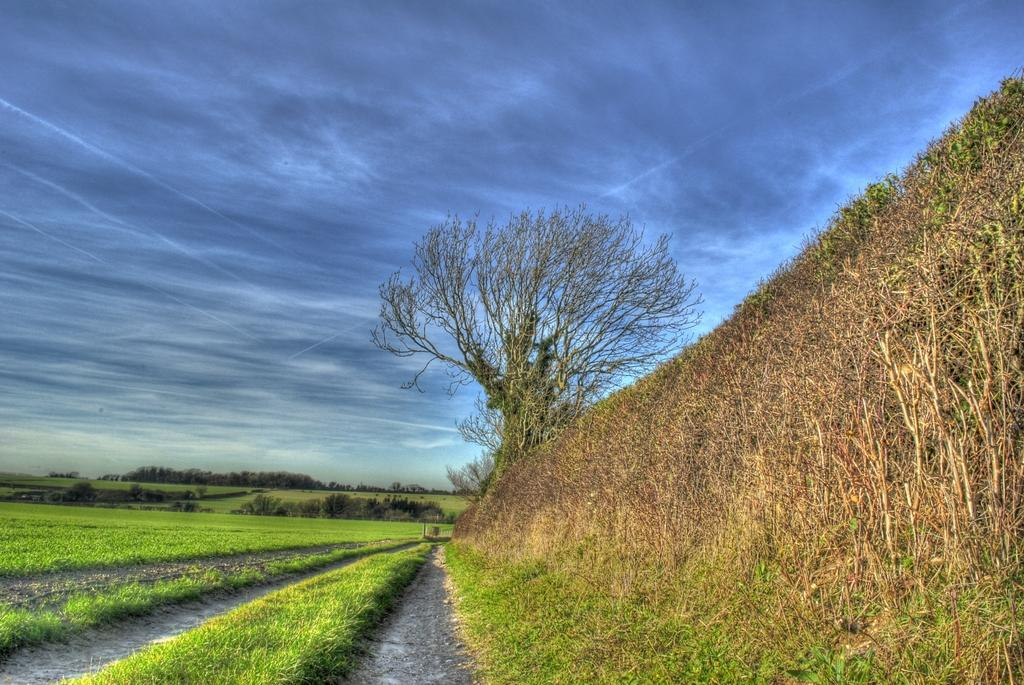What type of vegetation is present in the image? There is grass in the image. What can be seen in the background of the image? There are trees in the background of the image. What is visible at the top of the image? The sky is visible at the top of the image. What type of appliance can be seen in the image? There is no appliance present in the image. Can you describe the taste of the sea in the image? There is no sea present in the image, so it is not possible to describe its taste. 